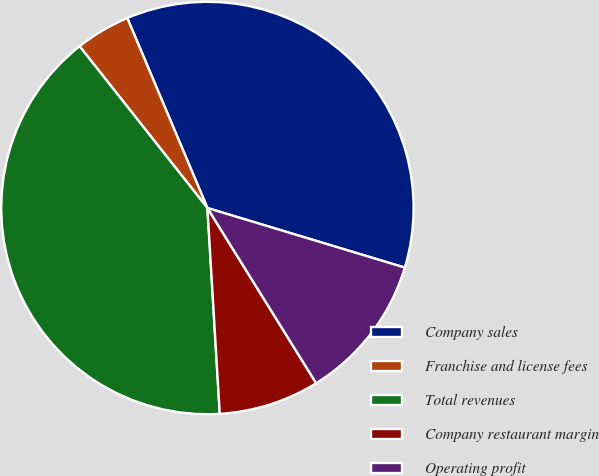Convert chart to OTSL. <chart><loc_0><loc_0><loc_500><loc_500><pie_chart><fcel>Company sales<fcel>Franchise and license fees<fcel>Total revenues<fcel>Company restaurant margin<fcel>Operating profit<nl><fcel>36.02%<fcel>4.29%<fcel>40.31%<fcel>7.89%<fcel>11.49%<nl></chart> 